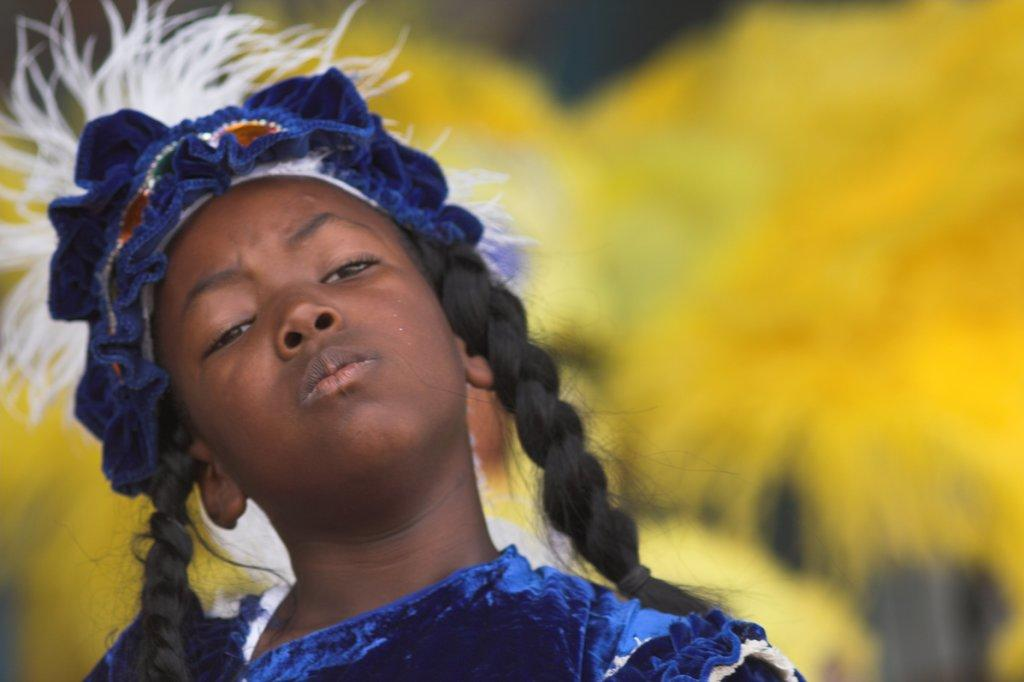Who is the main subject in the image? There is a girl in the image. What is the girl wearing? The girl is wearing a costume. Can you describe the background of the image? The background of the image is blurry. How many cans are visible in the image? There are no cans present in the image. What is the girl using her finger for in the image? There is no indication in the image that the girl is using her finger for any specific purpose. 